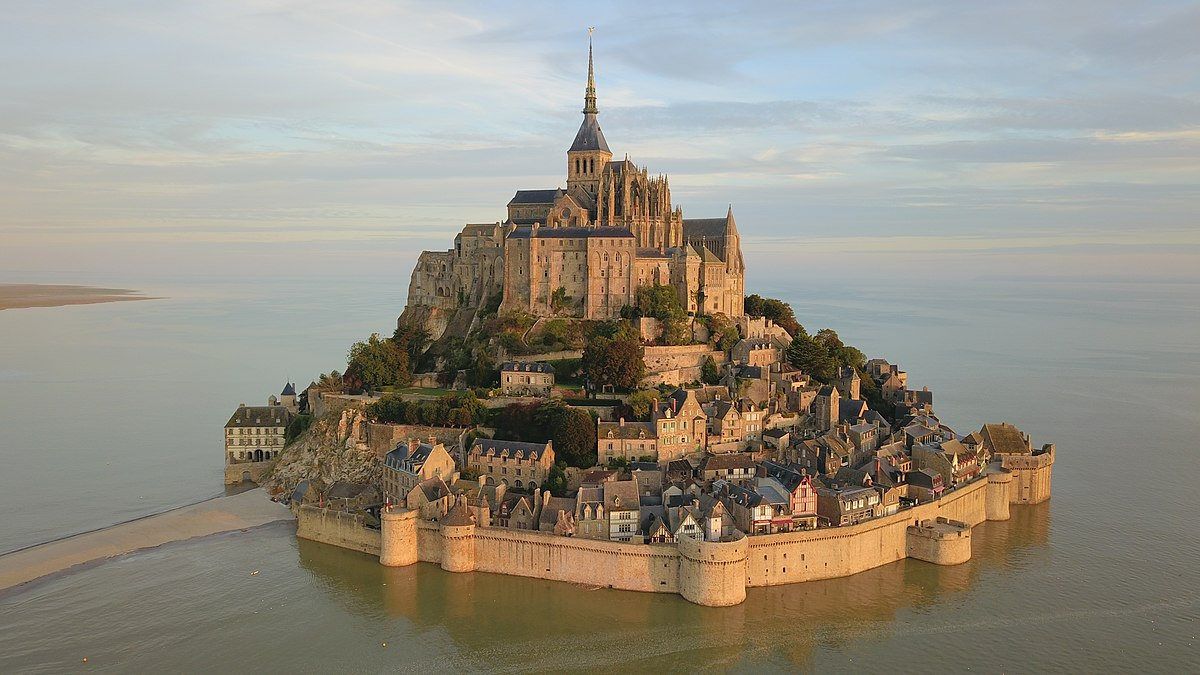Can you imagine this place at night, aglow with a thousand lanterns? As night falls over Mont St Michel, the island transforms into a mystical beacon aglow with a thousand lanterns. Soft, golden lights flicker from every window of the stone buildings, casting dancing shadows on the cobblestone streets. The abbey’s spire stands majestically illuminated, reflecting off the surrounding waters with a shimmering, almost otherworldly glow. The fortifications, now lit from within, give the impression of a glowing fortress from an ancient fairy tale. The narrow alleyways and winding paths are bathed in a warm light, inviting late-night wanderers to explore their hidden corners. The gentle hum of evening prayers from the abbey provides a serene soundtrack to the magical scene. Lanterns bob on the gentle waves, creating a mesmerizing pattern of light and water, while the full moon above casts a silvery light, adding to the ethereal ambiance. The entire island looks like a living painting of tranquility and ancient magic, suspended between reality and a dream. 